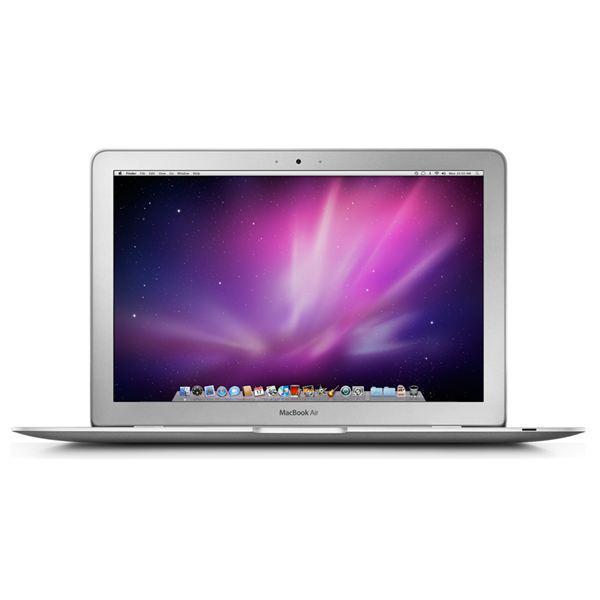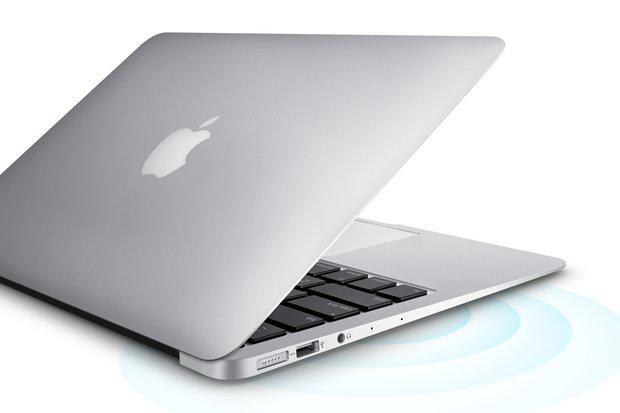The first image is the image on the left, the second image is the image on the right. Considering the images on both sides, is "In at least one of the photos, the screen is seen bent in at a sharp angle." valid? Answer yes or no. Yes. The first image is the image on the left, the second image is the image on the right. Evaluate the accuracy of this statement regarding the images: "The logo on the back of the laptop is clearly visible in at least one image.". Is it true? Answer yes or no. Yes. 